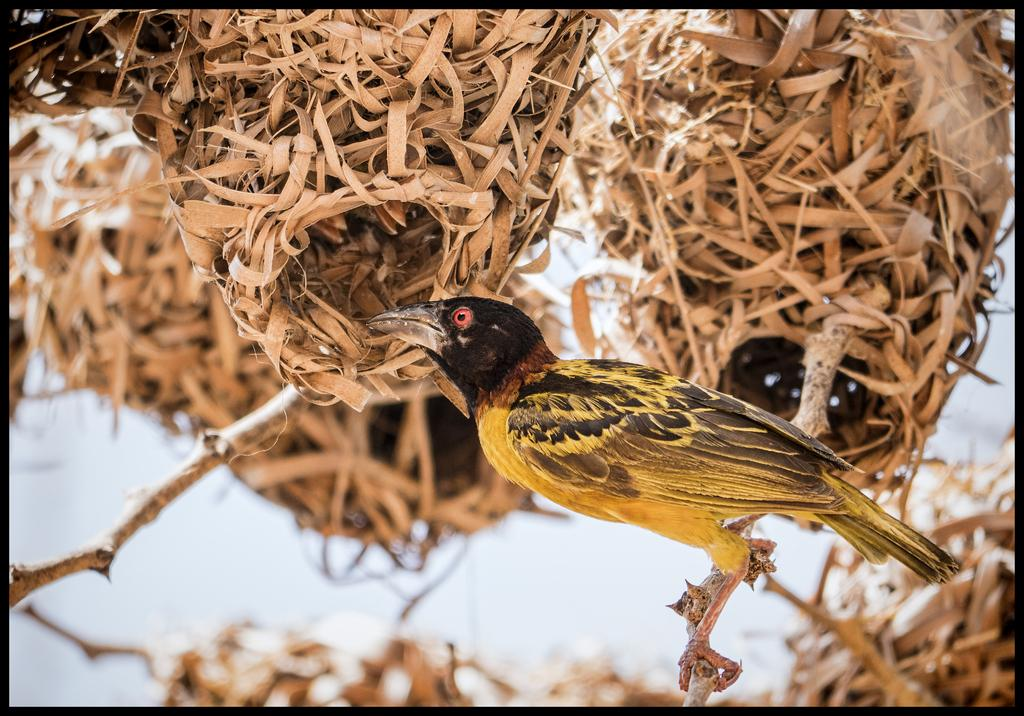What is the main subject of the image? There is a bird in the center of the image. Where is the bird located? The bird is on a stem. What can be seen in the background of the image? There are nests and the sky visible in the background of the image. What type of potato is being used as a perch for the bird in the image? There is no potato present in the image; the bird is on a stem. Can you see any crackers in the image? There are no crackers present in the image. 